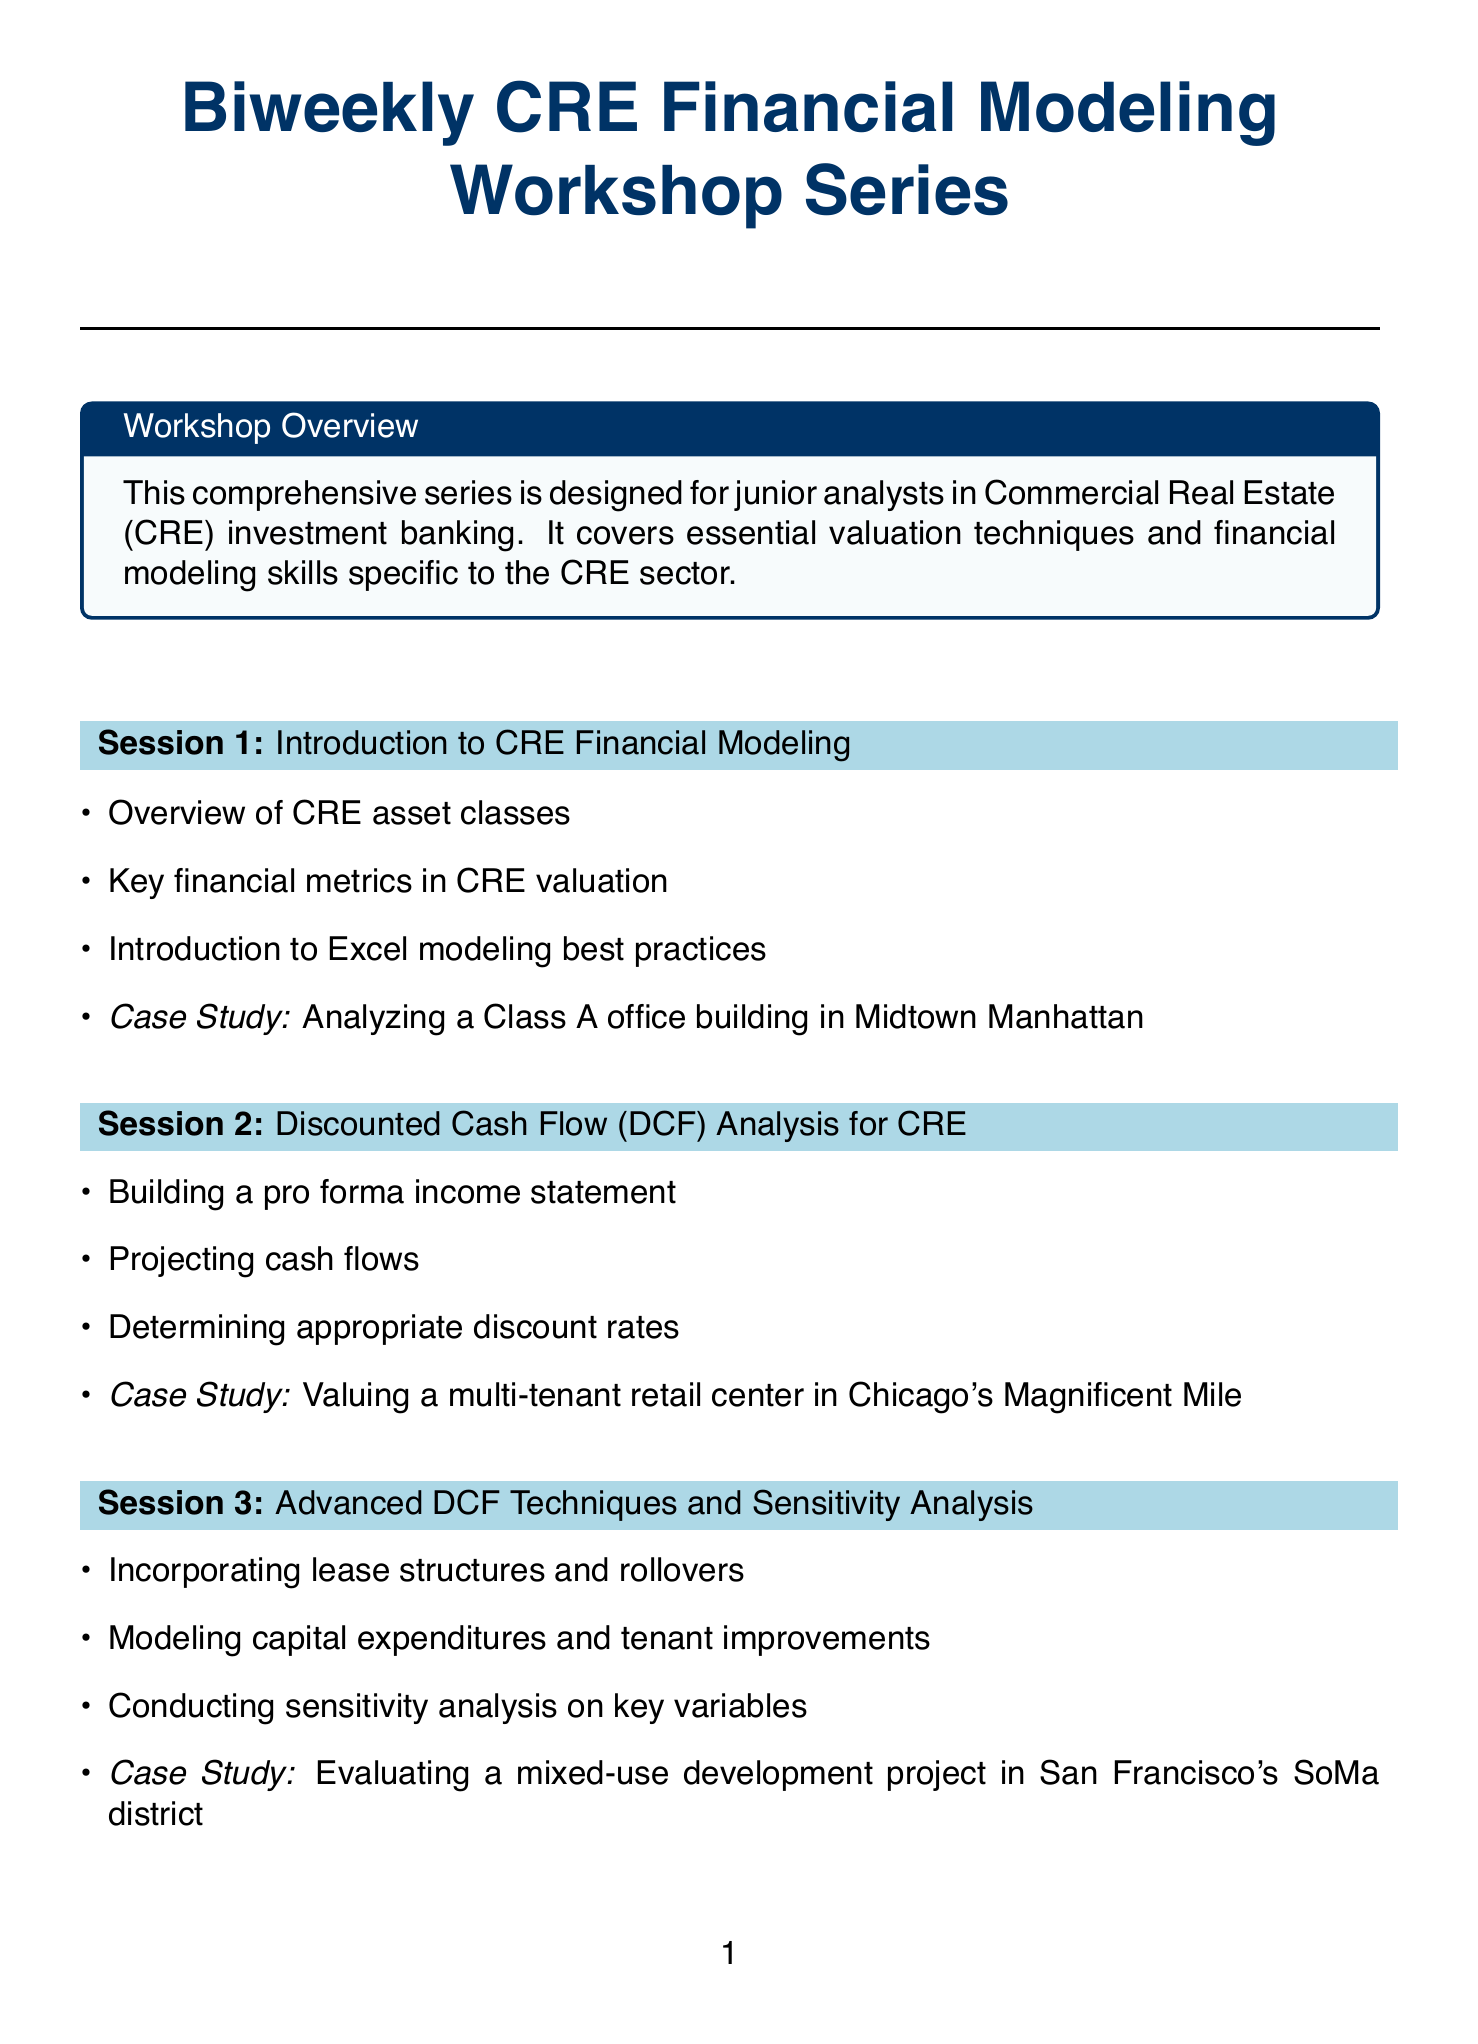What is the title of the first session? The title of the first session is provided in the list of sessions, which states "Introduction to CRE Financial Modeling."
Answer: Introduction to CRE Financial Modeling How many sessions are in the workshop series? The total number of sessions can be counted from the workshop series list, which shows 10 sessions.
Answer: 10 What is the case study for the fourth session? The case study can be found in the details of the fourth session, which states "Valuing a portfolio of industrial properties in the Inland Empire region."
Answer: Valuing a portfolio of industrial properties in the Inland Empire region What financial metric is specifically mentioned in the eighth session's topics? The topics listed in the eighth session include REIT-specific metrics such as FFO, AFFO, and NAV.
Answer: FFO, AFFO, NAV Which session focuses on Advanced DCF Techniques? The session number and title for advanced techniques appear as session 3 titled "Advanced DCF Techniques and Sensitivity Analysis."
Answer: Session 3 How does the workshop series cater to junior analysts? The document describes the purpose of the workshop series tailored specifically for junior analysts in Commercial Real Estate investment banking.
Answer: Junior analysts in Commercial Real Estate investment banking What specific aspect does the last session focus on regarding market trends? The last session addresses "analyzing the impact of remote work on office valuations," indicating its focus on current market trends.
Answer: Analyzing the impact of remote work on office valuations What is covered in the second session related to cash flow? The topics in the second session mention "projecting cash flows" as part of Discounted Cash Flow (DCF) analysis.
Answer: Projecting cash flows What modeling concept is introduced in the sixth session? The sixth session introduces modeling different loan structures, as mentioned in the topics.
Answer: Different loan structures 